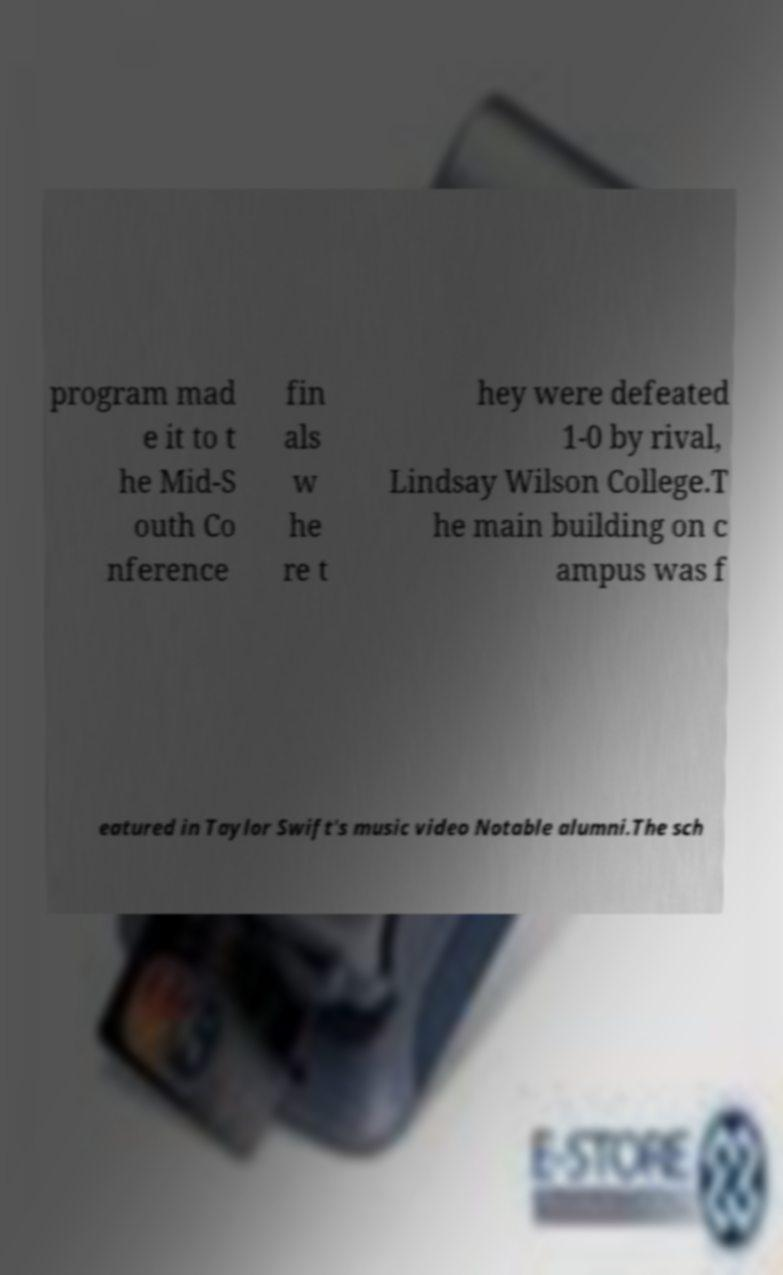Please read and relay the text visible in this image. What does it say? program mad e it to t he Mid-S outh Co nference fin als w he re t hey were defeated 1-0 by rival, Lindsay Wilson College.T he main building on c ampus was f eatured in Taylor Swift's music video Notable alumni.The sch 